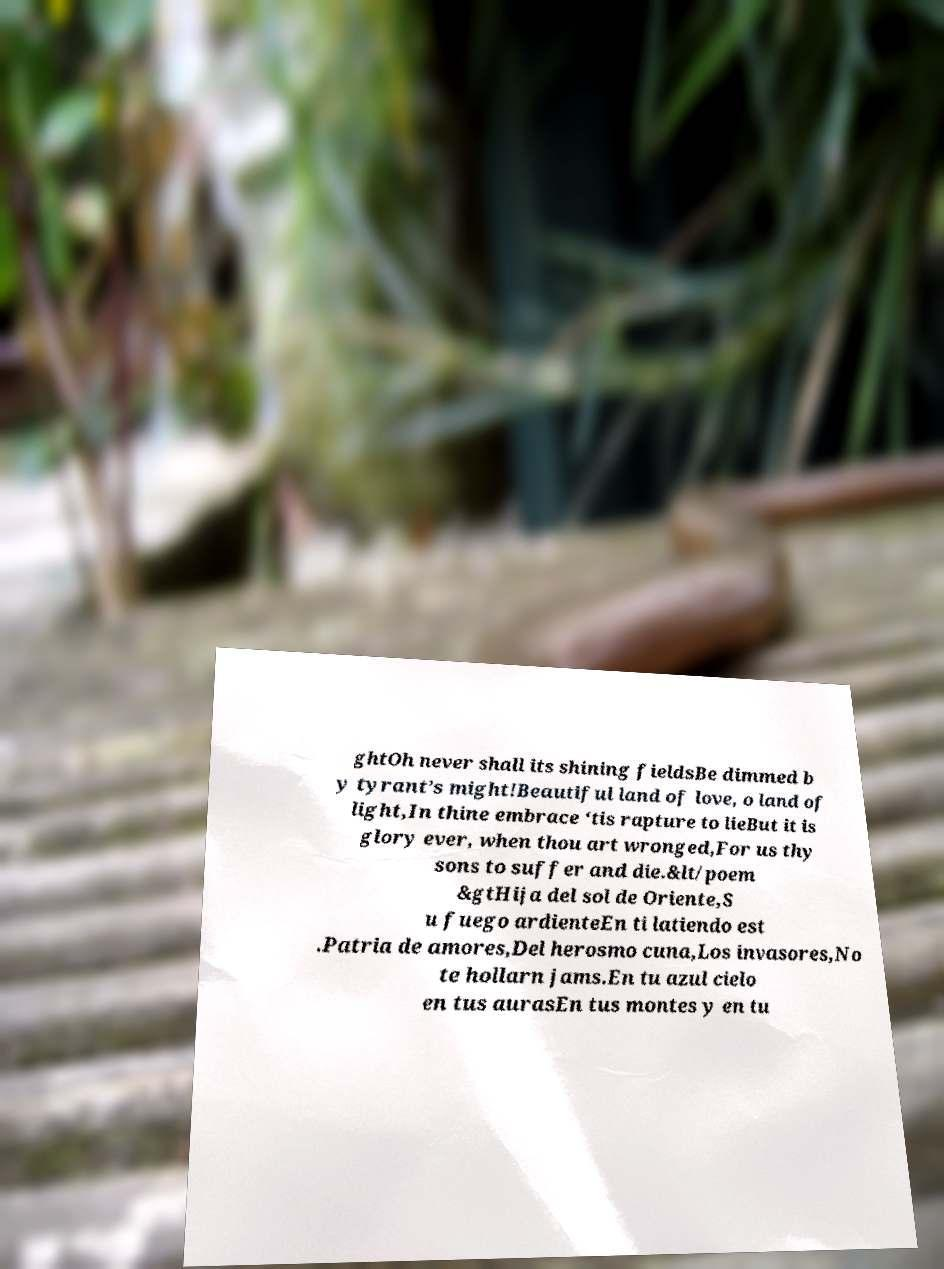Please read and relay the text visible in this image. What does it say? ghtOh never shall its shining fieldsBe dimmed b y tyrant’s might!Beautiful land of love, o land of light,In thine embrace ‘tis rapture to lieBut it is glory ever, when thou art wronged,For us thy sons to suffer and die.&lt/poem &gtHija del sol de Oriente,S u fuego ardienteEn ti latiendo est .Patria de amores,Del herosmo cuna,Los invasores,No te hollarn jams.En tu azul cielo en tus aurasEn tus montes y en tu 